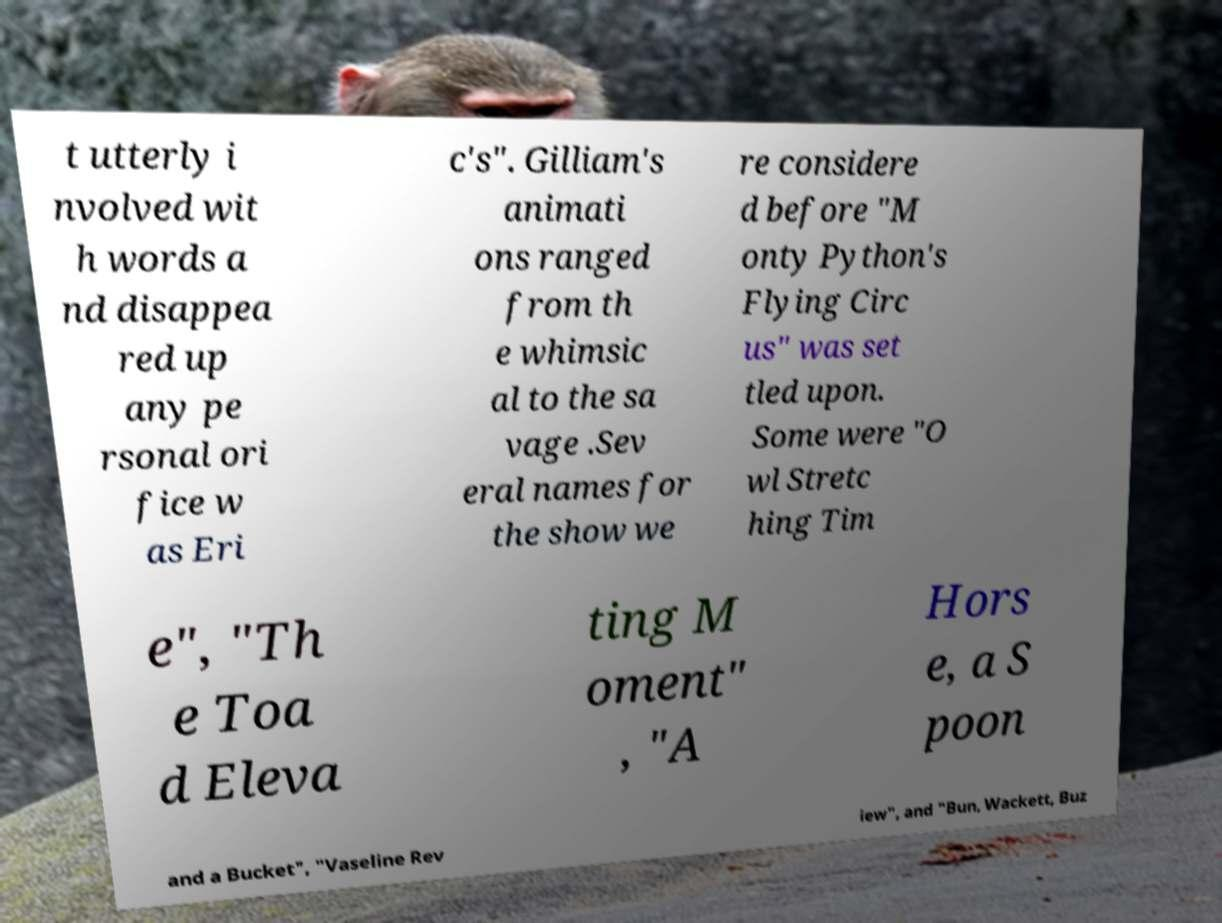Please read and relay the text visible in this image. What does it say? t utterly i nvolved wit h words a nd disappea red up any pe rsonal ori fice w as Eri c's". Gilliam's animati ons ranged from th e whimsic al to the sa vage .Sev eral names for the show we re considere d before "M onty Python's Flying Circ us" was set tled upon. Some were "O wl Stretc hing Tim e", "Th e Toa d Eleva ting M oment" , "A Hors e, a S poon and a Bucket", "Vaseline Rev iew", and "Bun, Wackett, Buz 